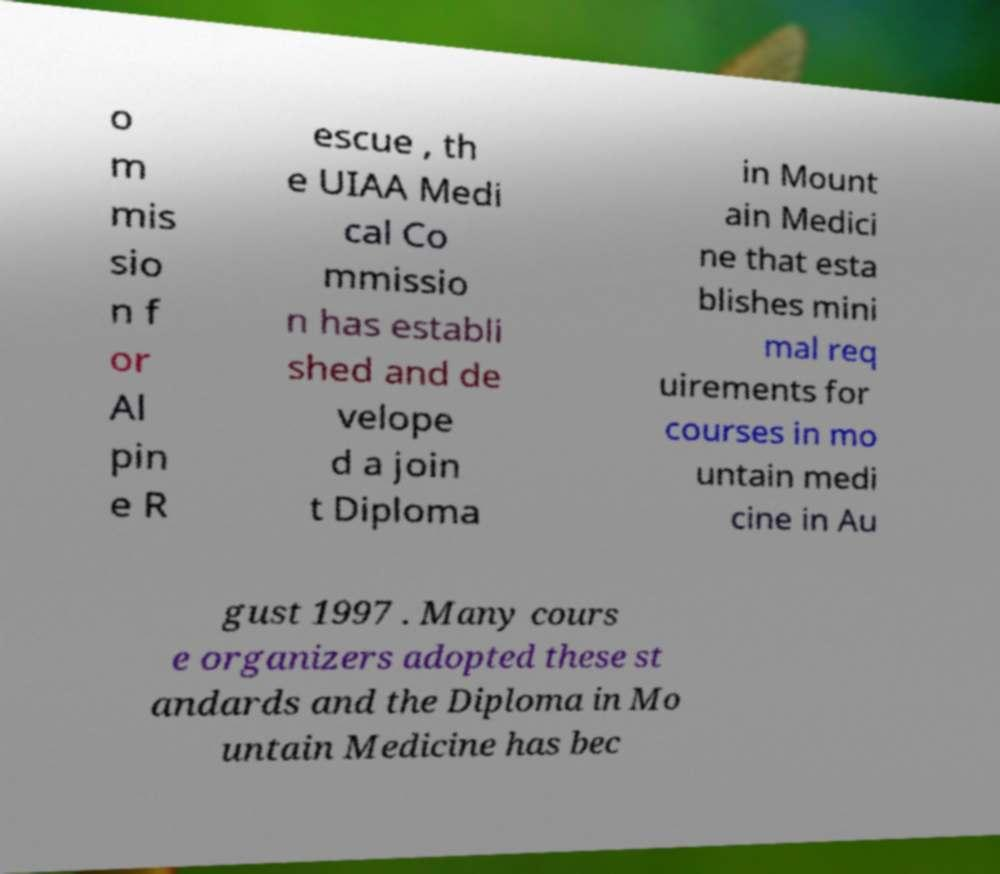Can you accurately transcribe the text from the provided image for me? o m mis sio n f or Al pin e R escue , th e UIAA Medi cal Co mmissio n has establi shed and de velope d a join t Diploma in Mount ain Medici ne that esta blishes mini mal req uirements for courses in mo untain medi cine in Au gust 1997 . Many cours e organizers adopted these st andards and the Diploma in Mo untain Medicine has bec 